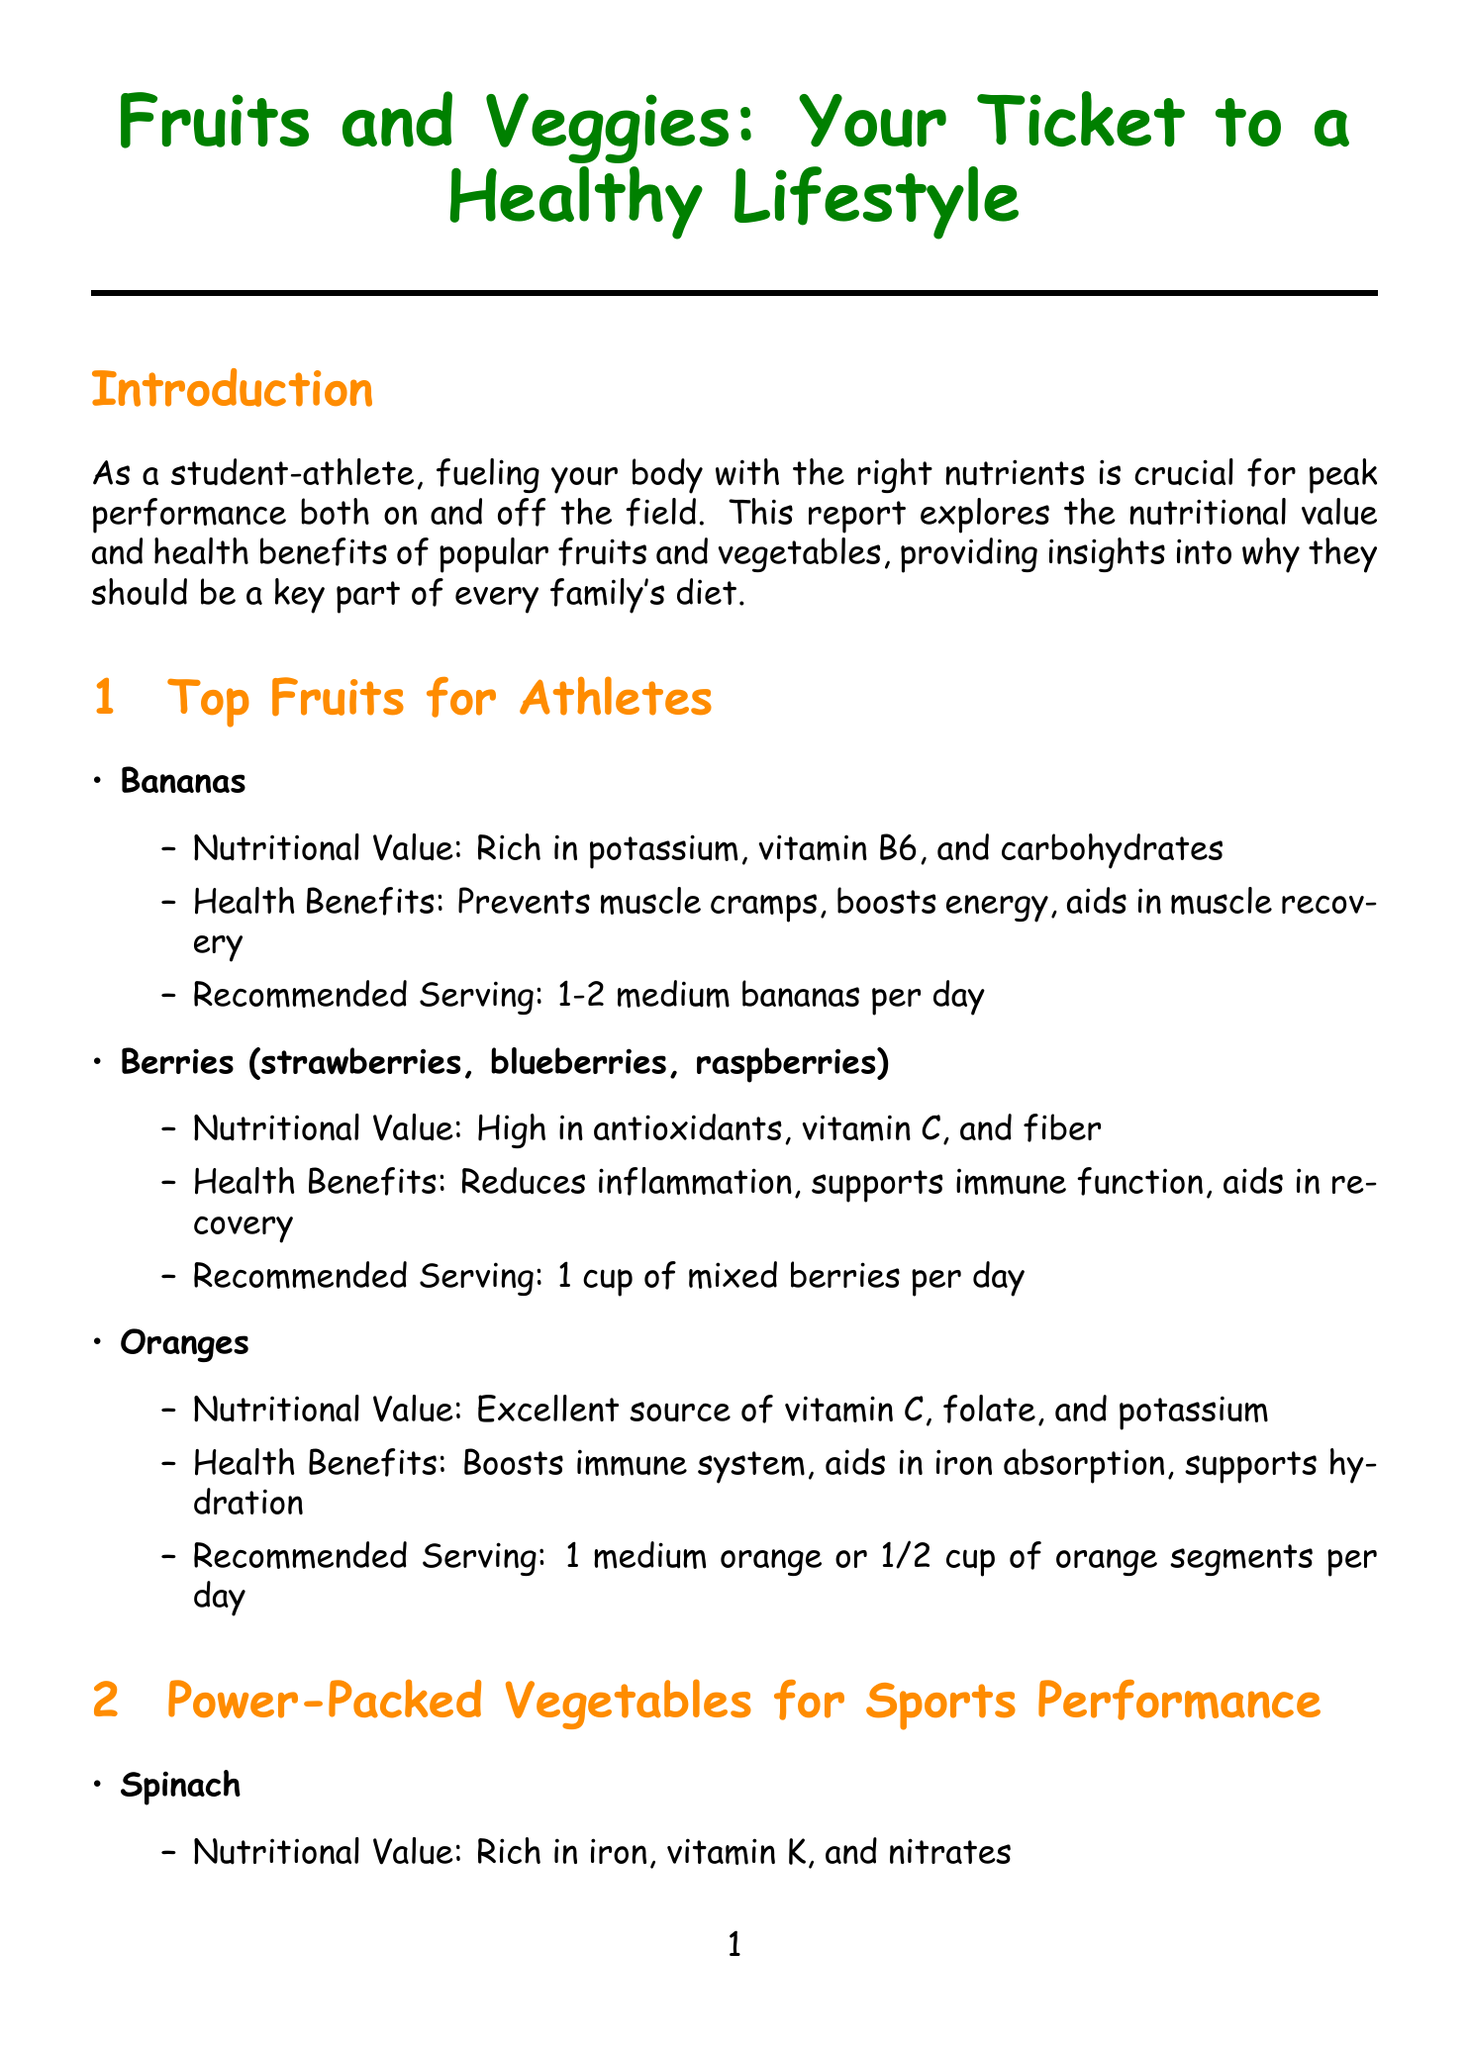what are the recommended servings of bananas? The recommended serving for bananas is stated clearly in the nutritional section, which indicates 1-2 medium bananas per day.
Answer: 1-2 medium bananas per day what nutrients are found in broccoli? The document lists the nutritional values of broccoli, which includes vitamin C, vitamin K, and sulforaphane.
Answer: Vitamin C, vitamin K, sulforaphane what is a health benefit of eating cherries? The report provides specific health benefits of cherries, stating it reduces muscle damage, improves sleep quality, and speeds up recovery.
Answer: Reduces muscle damage how can spinach benefit a student-athlete? A reasoning question that combines the health benefits of spinach included in the document, such as improving oxygen transport and enhancing muscle function.
Answer: Improves oxygen transport how many servings of sweet potatoes are recommended? The document specifies that the recommended serving of sweet potatoes is given clearly under the vegetable section.
Answer: 1 medium sweet potato per day what is the title of the report? The title is presented prominently at the top of the document as a key element of its structure.
Answer: Fruits and Veggies: Your Ticket to a Healthy Lifestyle what does the conclusion emphasize about fruits and vegetables? The conclusion summarizes the importance of fruits and vegetables, emphasizing their role in athletic performance and health.
Answer: Essential for optimal athletic performance and overall health what does "USDA MyPlate" provide? The additional resources section outlines what each resource offers, indicating that USDA MyPlate provides official dietary guidelines.
Answer: Official dietary guidelines 